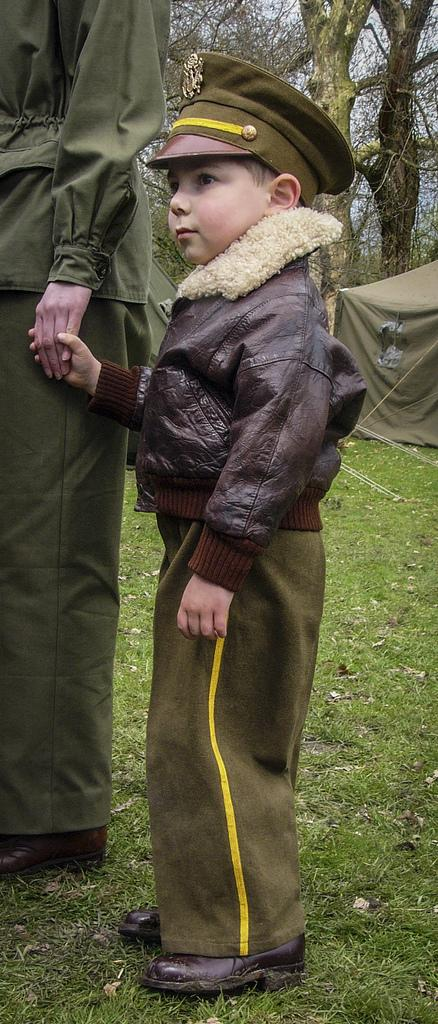Who is in the image with the boy? The boy is holding the hand of a human. What is the boy wearing on his head? The boy is wearing a cap on his head. What type of shelter is visible in the image? There is a tent in the image. What can be seen in the background of the image? There are trees in the background of the image. What is the ground made of in the image? Grass is present on the ground in the image. What type of bird is the boy trying to rub with a wren in the image? There is no bird or wren present in the image; the boy is holding the hand of a human. 